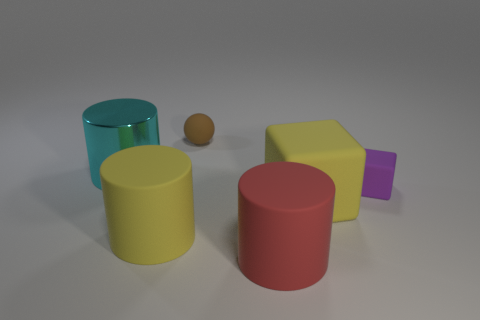Are there any other things that are the same material as the large cyan object?
Give a very brief answer. No. There is a large cylinder behind the yellow cube; what is its material?
Offer a terse response. Metal. Is the number of yellow cubes greater than the number of brown shiny cubes?
Your response must be concise. Yes. Does the yellow rubber thing on the left side of the tiny ball have the same shape as the big red matte thing?
Offer a very short reply. Yes. What number of objects are both to the right of the cyan cylinder and behind the small purple thing?
Offer a very short reply. 1. How many yellow objects are the same shape as the cyan thing?
Offer a very short reply. 1. The cylinder that is right of the big yellow cylinder that is to the left of the brown ball is what color?
Your answer should be very brief. Red. There is a small brown matte thing; does it have the same shape as the big yellow matte thing that is to the left of the yellow matte cube?
Offer a very short reply. No. What is the big cylinder behind the yellow matte object on the left side of the big yellow rubber object to the right of the big red object made of?
Keep it short and to the point. Metal. Is there a block that has the same size as the brown object?
Offer a terse response. Yes. 